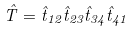<formula> <loc_0><loc_0><loc_500><loc_500>\hat { T } = \hat { t } _ { 1 2 } \hat { t } _ { 2 3 } \hat { t } _ { 3 4 } \hat { t } _ { 4 1 }</formula> 